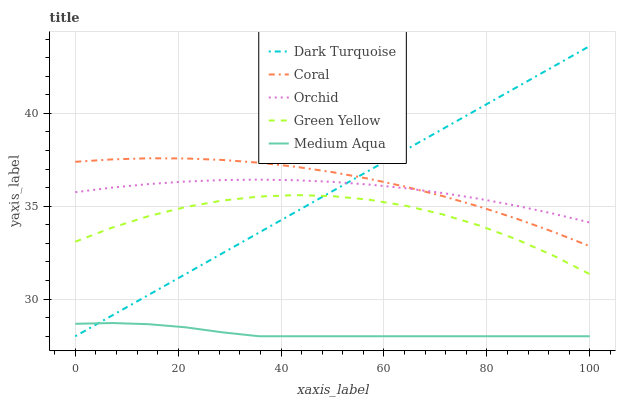Does Medium Aqua have the minimum area under the curve?
Answer yes or no. Yes. Does Coral have the maximum area under the curve?
Answer yes or no. Yes. Does Green Yellow have the minimum area under the curve?
Answer yes or no. No. Does Green Yellow have the maximum area under the curve?
Answer yes or no. No. Is Dark Turquoise the smoothest?
Answer yes or no. Yes. Is Green Yellow the roughest?
Answer yes or no. Yes. Is Coral the smoothest?
Answer yes or no. No. Is Coral the roughest?
Answer yes or no. No. Does Dark Turquoise have the lowest value?
Answer yes or no. Yes. Does Coral have the lowest value?
Answer yes or no. No. Does Dark Turquoise have the highest value?
Answer yes or no. Yes. Does Coral have the highest value?
Answer yes or no. No. Is Medium Aqua less than Orchid?
Answer yes or no. Yes. Is Orchid greater than Green Yellow?
Answer yes or no. Yes. Does Coral intersect Orchid?
Answer yes or no. Yes. Is Coral less than Orchid?
Answer yes or no. No. Is Coral greater than Orchid?
Answer yes or no. No. Does Medium Aqua intersect Orchid?
Answer yes or no. No. 